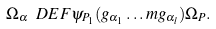Convert formula to latex. <formula><loc_0><loc_0><loc_500><loc_500>\Omega _ { \alpha } \ D E F \psi _ { P _ { 1 } } ( g _ { \alpha _ { 1 } } \dots m g _ { \alpha _ { l } } ) \Omega _ { P } .</formula> 